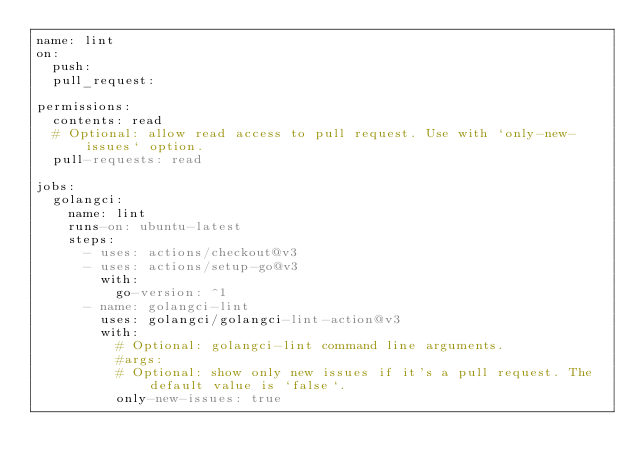<code> <loc_0><loc_0><loc_500><loc_500><_YAML_>name: lint
on:
  push:
  pull_request:

permissions:
  contents: read
  # Optional: allow read access to pull request. Use with `only-new-issues` option.
  pull-requests: read

jobs:
  golangci:
    name: lint
    runs-on: ubuntu-latest
    steps:
      - uses: actions/checkout@v3
      - uses: actions/setup-go@v3
        with:
          go-version: ^1
      - name: golangci-lint
        uses: golangci/golangci-lint-action@v3
        with:
          # Optional: golangci-lint command line arguments.
          #args:
          # Optional: show only new issues if it's a pull request. The default value is `false`.
          only-new-issues: true
</code> 